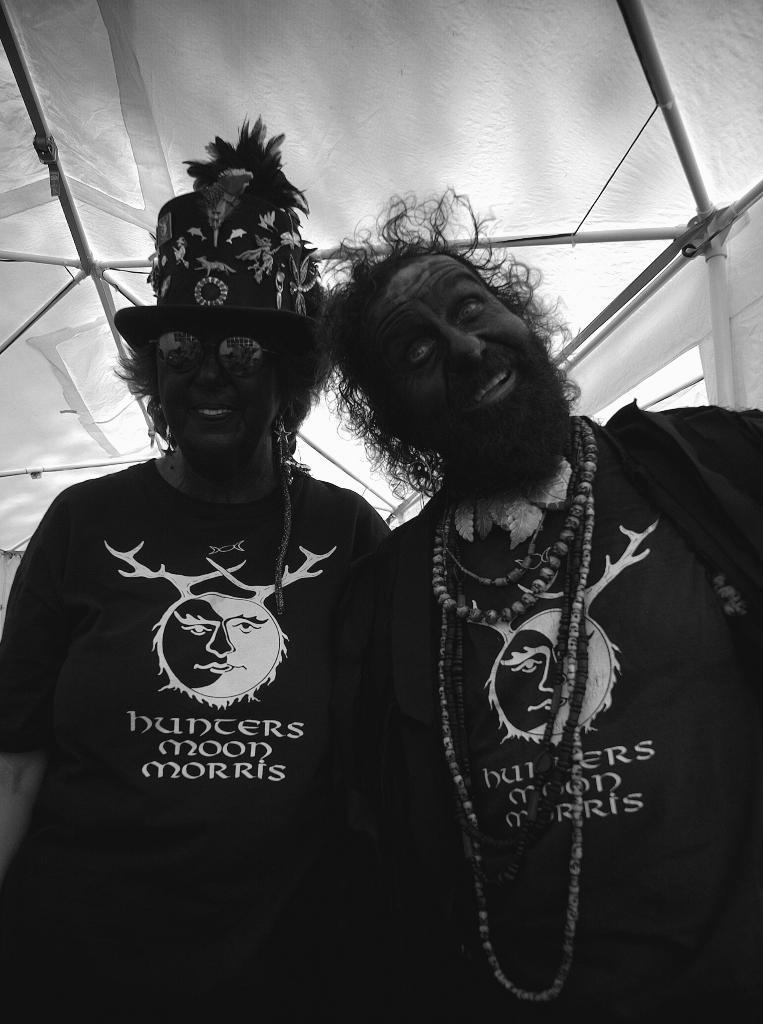Please provide a concise description of this image. In this picture we can see a man and beside to him a woman wore cap, goggle and smiling and in the background we can see rods. 